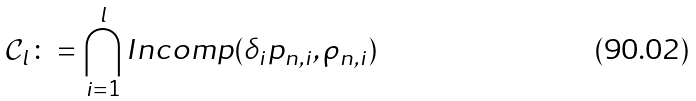<formula> <loc_0><loc_0><loc_500><loc_500>\mathcal { C } _ { l } \colon = \bigcap _ { i = 1 } ^ { l } I n c o m p ( \delta _ { i } p _ { n , i } , \rho _ { n , i } )</formula> 